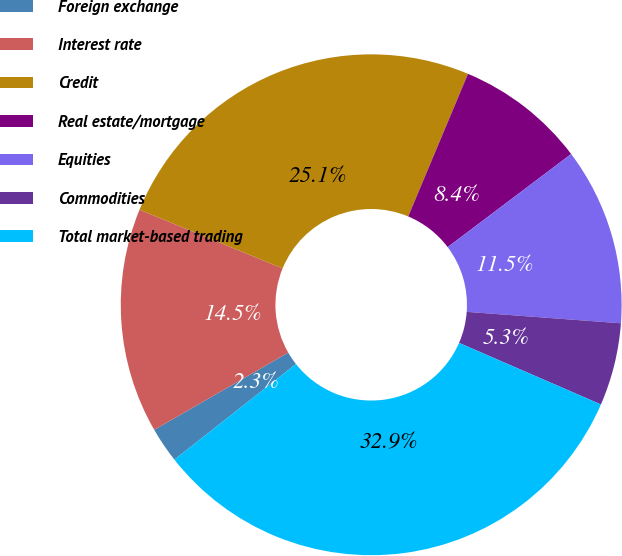Convert chart to OTSL. <chart><loc_0><loc_0><loc_500><loc_500><pie_chart><fcel>Foreign exchange<fcel>Interest rate<fcel>Credit<fcel>Real estate/mortgage<fcel>Equities<fcel>Commodities<fcel>Total market-based trading<nl><fcel>2.29%<fcel>14.52%<fcel>25.12%<fcel>8.4%<fcel>11.46%<fcel>5.34%<fcel>32.87%<nl></chart> 